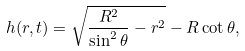<formula> <loc_0><loc_0><loc_500><loc_500>h ( r , t ) = \sqrt { \frac { R ^ { 2 } } { \sin ^ { 2 } \theta } - r ^ { 2 } } - R \cot \theta ,</formula> 